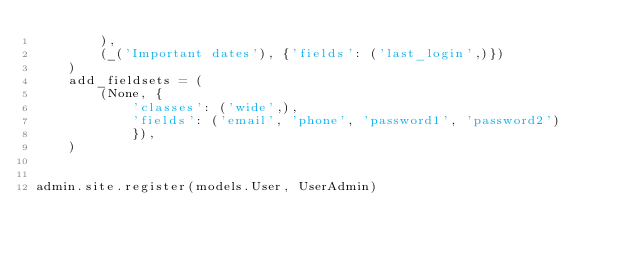<code> <loc_0><loc_0><loc_500><loc_500><_Python_>        ),
        (_('Important dates'), {'fields': ('last_login',)})
    )
    add_fieldsets = (
        (None, {
            'classes': ('wide',),
            'fields': ('email', 'phone', 'password1', 'password2')
            }),
    )


admin.site.register(models.User, UserAdmin)
</code> 